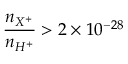<formula> <loc_0><loc_0><loc_500><loc_500>{ \frac { n _ { X ^ { + } } } { n _ { H ^ { + } } } } > 2 \times 1 0 ^ { - 2 8 }</formula> 